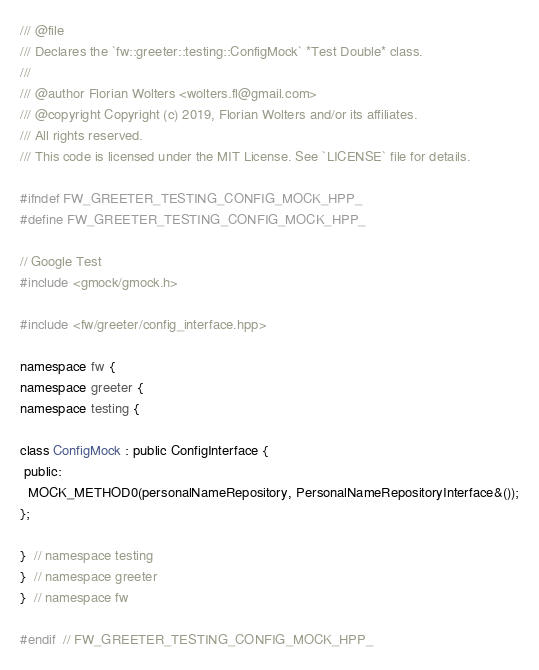<code> <loc_0><loc_0><loc_500><loc_500><_C++_>/// @file
/// Declares the `fw::greeter::testing::ConfigMock` *Test Double* class.
///
/// @author Florian Wolters <wolters.fl@gmail.com>
/// @copyright Copyright (c) 2019, Florian Wolters and/or its affiliates.
/// All rights reserved.
/// This code is licensed under the MIT License. See `LICENSE` file for details.

#ifndef FW_GREETER_TESTING_CONFIG_MOCK_HPP_
#define FW_GREETER_TESTING_CONFIG_MOCK_HPP_

// Google Test
#include <gmock/gmock.h>

#include <fw/greeter/config_interface.hpp>

namespace fw {
namespace greeter {
namespace testing {

class ConfigMock : public ConfigInterface {
 public:
  MOCK_METHOD0(personalNameRepository, PersonalNameRepositoryInterface&());
};

}  // namespace testing
}  // namespace greeter
}  // namespace fw

#endif  // FW_GREETER_TESTING_CONFIG_MOCK_HPP_
</code> 